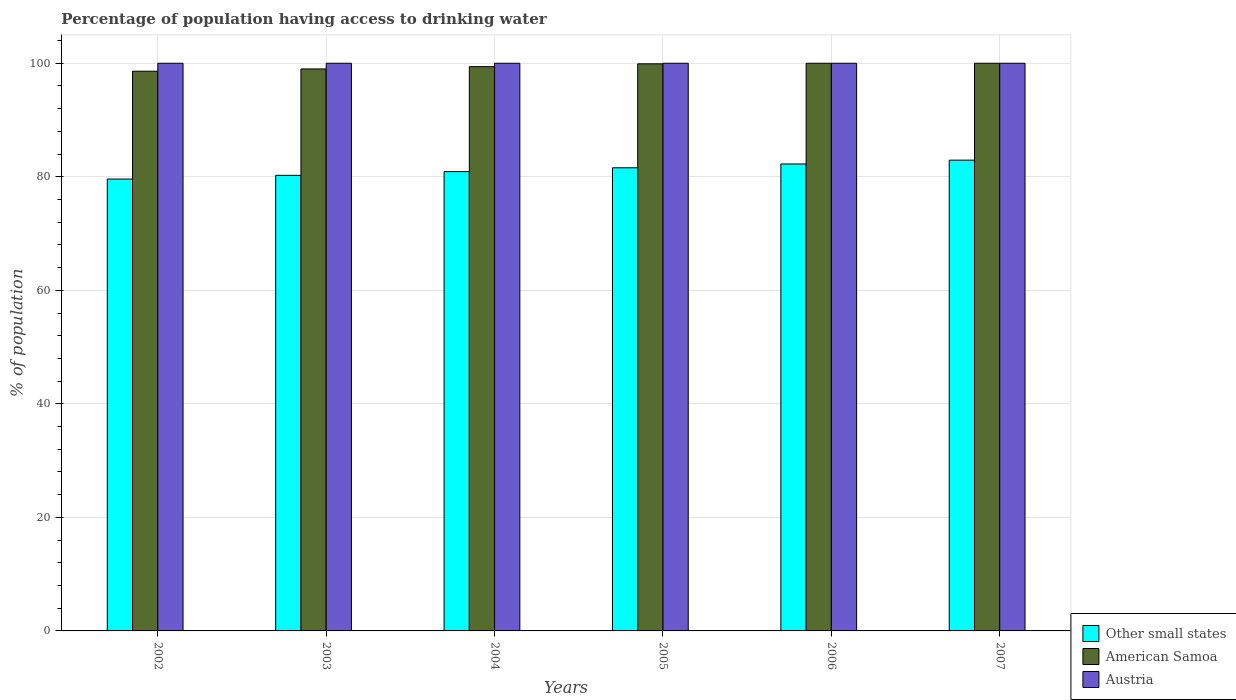How many different coloured bars are there?
Provide a short and direct response. 3. How many groups of bars are there?
Give a very brief answer. 6. Are the number of bars on each tick of the X-axis equal?
Give a very brief answer. Yes. How many bars are there on the 3rd tick from the left?
Offer a very short reply. 3. What is the label of the 2nd group of bars from the left?
Provide a short and direct response. 2003. In how many cases, is the number of bars for a given year not equal to the number of legend labels?
Make the answer very short. 0. What is the percentage of population having access to drinking water in American Samoa in 2005?
Your answer should be compact. 99.9. Across all years, what is the maximum percentage of population having access to drinking water in American Samoa?
Offer a terse response. 100. Across all years, what is the minimum percentage of population having access to drinking water in Austria?
Offer a very short reply. 100. In which year was the percentage of population having access to drinking water in Austria minimum?
Your response must be concise. 2002. What is the total percentage of population having access to drinking water in Austria in the graph?
Your response must be concise. 600. What is the difference between the percentage of population having access to drinking water in Other small states in 2005 and that in 2007?
Your answer should be very brief. -1.35. What is the difference between the percentage of population having access to drinking water in Austria in 2005 and the percentage of population having access to drinking water in Other small states in 2006?
Provide a succinct answer. 17.74. In the year 2005, what is the difference between the percentage of population having access to drinking water in American Samoa and percentage of population having access to drinking water in Other small states?
Make the answer very short. 18.31. What is the ratio of the percentage of population having access to drinking water in Other small states in 2002 to that in 2005?
Offer a very short reply. 0.98. What is the difference between the highest and the second highest percentage of population having access to drinking water in Other small states?
Give a very brief answer. 0.68. What is the difference between the highest and the lowest percentage of population having access to drinking water in Other small states?
Your answer should be very brief. 3.33. In how many years, is the percentage of population having access to drinking water in Other small states greater than the average percentage of population having access to drinking water in Other small states taken over all years?
Your answer should be compact. 3. Is the sum of the percentage of population having access to drinking water in Austria in 2003 and 2006 greater than the maximum percentage of population having access to drinking water in Other small states across all years?
Provide a succinct answer. Yes. What does the 3rd bar from the left in 2005 represents?
Your answer should be very brief. Austria. What does the 3rd bar from the right in 2003 represents?
Offer a very short reply. Other small states. Is it the case that in every year, the sum of the percentage of population having access to drinking water in American Samoa and percentage of population having access to drinking water in Other small states is greater than the percentage of population having access to drinking water in Austria?
Ensure brevity in your answer.  Yes. How many bars are there?
Your answer should be very brief. 18. Are all the bars in the graph horizontal?
Offer a terse response. No. How many years are there in the graph?
Offer a very short reply. 6. What is the difference between two consecutive major ticks on the Y-axis?
Provide a succinct answer. 20. Are the values on the major ticks of Y-axis written in scientific E-notation?
Provide a succinct answer. No. Does the graph contain any zero values?
Make the answer very short. No. Where does the legend appear in the graph?
Your response must be concise. Bottom right. What is the title of the graph?
Offer a very short reply. Percentage of population having access to drinking water. What is the label or title of the X-axis?
Offer a very short reply. Years. What is the label or title of the Y-axis?
Ensure brevity in your answer.  % of population. What is the % of population in Other small states in 2002?
Offer a very short reply. 79.61. What is the % of population of American Samoa in 2002?
Make the answer very short. 98.6. What is the % of population in Other small states in 2003?
Your answer should be compact. 80.26. What is the % of population of American Samoa in 2003?
Your answer should be compact. 99. What is the % of population in Other small states in 2004?
Make the answer very short. 80.91. What is the % of population of American Samoa in 2004?
Ensure brevity in your answer.  99.4. What is the % of population in Other small states in 2005?
Your answer should be very brief. 81.59. What is the % of population in American Samoa in 2005?
Keep it short and to the point. 99.9. What is the % of population of Other small states in 2006?
Offer a very short reply. 82.26. What is the % of population of Austria in 2006?
Ensure brevity in your answer.  100. What is the % of population in Other small states in 2007?
Your answer should be very brief. 82.94. What is the % of population of American Samoa in 2007?
Offer a very short reply. 100. Across all years, what is the maximum % of population in Other small states?
Offer a very short reply. 82.94. Across all years, what is the minimum % of population in Other small states?
Provide a short and direct response. 79.61. Across all years, what is the minimum % of population of American Samoa?
Provide a succinct answer. 98.6. What is the total % of population of Other small states in the graph?
Provide a short and direct response. 487.56. What is the total % of population of American Samoa in the graph?
Give a very brief answer. 596.9. What is the total % of population in Austria in the graph?
Your answer should be very brief. 600. What is the difference between the % of population of Other small states in 2002 and that in 2003?
Your answer should be compact. -0.65. What is the difference between the % of population of American Samoa in 2002 and that in 2003?
Provide a succinct answer. -0.4. What is the difference between the % of population in Austria in 2002 and that in 2003?
Your answer should be compact. 0. What is the difference between the % of population of Other small states in 2002 and that in 2004?
Keep it short and to the point. -1.31. What is the difference between the % of population of American Samoa in 2002 and that in 2004?
Provide a short and direct response. -0.8. What is the difference between the % of population of Austria in 2002 and that in 2004?
Make the answer very short. 0. What is the difference between the % of population in Other small states in 2002 and that in 2005?
Your answer should be compact. -1.98. What is the difference between the % of population of Other small states in 2002 and that in 2006?
Keep it short and to the point. -2.65. What is the difference between the % of population in Austria in 2002 and that in 2006?
Your answer should be compact. 0. What is the difference between the % of population in Other small states in 2002 and that in 2007?
Your response must be concise. -3.33. What is the difference between the % of population of Austria in 2002 and that in 2007?
Your answer should be very brief. 0. What is the difference between the % of population of Other small states in 2003 and that in 2004?
Provide a short and direct response. -0.66. What is the difference between the % of population in Other small states in 2003 and that in 2005?
Ensure brevity in your answer.  -1.33. What is the difference between the % of population of American Samoa in 2003 and that in 2005?
Provide a succinct answer. -0.9. What is the difference between the % of population in Other small states in 2003 and that in 2006?
Ensure brevity in your answer.  -2. What is the difference between the % of population in Other small states in 2003 and that in 2007?
Provide a succinct answer. -2.68. What is the difference between the % of population in American Samoa in 2003 and that in 2007?
Give a very brief answer. -1. What is the difference between the % of population in Austria in 2003 and that in 2007?
Provide a succinct answer. 0. What is the difference between the % of population of Other small states in 2004 and that in 2005?
Make the answer very short. -0.67. What is the difference between the % of population of American Samoa in 2004 and that in 2005?
Make the answer very short. -0.5. What is the difference between the % of population in Other small states in 2004 and that in 2006?
Your answer should be compact. -1.34. What is the difference between the % of population in American Samoa in 2004 and that in 2006?
Keep it short and to the point. -0.6. What is the difference between the % of population of Austria in 2004 and that in 2006?
Provide a short and direct response. 0. What is the difference between the % of population of Other small states in 2004 and that in 2007?
Provide a short and direct response. -2.02. What is the difference between the % of population of Other small states in 2005 and that in 2006?
Your answer should be compact. -0.67. What is the difference between the % of population in Austria in 2005 and that in 2006?
Ensure brevity in your answer.  0. What is the difference between the % of population of Other small states in 2005 and that in 2007?
Your response must be concise. -1.35. What is the difference between the % of population of Other small states in 2006 and that in 2007?
Provide a short and direct response. -0.68. What is the difference between the % of population in American Samoa in 2006 and that in 2007?
Make the answer very short. 0. What is the difference between the % of population in Other small states in 2002 and the % of population in American Samoa in 2003?
Provide a short and direct response. -19.39. What is the difference between the % of population of Other small states in 2002 and the % of population of Austria in 2003?
Your response must be concise. -20.39. What is the difference between the % of population in Other small states in 2002 and the % of population in American Samoa in 2004?
Provide a succinct answer. -19.79. What is the difference between the % of population of Other small states in 2002 and the % of population of Austria in 2004?
Your answer should be very brief. -20.39. What is the difference between the % of population of American Samoa in 2002 and the % of population of Austria in 2004?
Your answer should be compact. -1.4. What is the difference between the % of population of Other small states in 2002 and the % of population of American Samoa in 2005?
Your answer should be compact. -20.29. What is the difference between the % of population of Other small states in 2002 and the % of population of Austria in 2005?
Your response must be concise. -20.39. What is the difference between the % of population of American Samoa in 2002 and the % of population of Austria in 2005?
Ensure brevity in your answer.  -1.4. What is the difference between the % of population of Other small states in 2002 and the % of population of American Samoa in 2006?
Your answer should be compact. -20.39. What is the difference between the % of population in Other small states in 2002 and the % of population in Austria in 2006?
Offer a terse response. -20.39. What is the difference between the % of population of Other small states in 2002 and the % of population of American Samoa in 2007?
Your answer should be compact. -20.39. What is the difference between the % of population in Other small states in 2002 and the % of population in Austria in 2007?
Give a very brief answer. -20.39. What is the difference between the % of population in Other small states in 2003 and the % of population in American Samoa in 2004?
Your answer should be very brief. -19.14. What is the difference between the % of population in Other small states in 2003 and the % of population in Austria in 2004?
Provide a succinct answer. -19.74. What is the difference between the % of population in American Samoa in 2003 and the % of population in Austria in 2004?
Make the answer very short. -1. What is the difference between the % of population in Other small states in 2003 and the % of population in American Samoa in 2005?
Your answer should be very brief. -19.64. What is the difference between the % of population of Other small states in 2003 and the % of population of Austria in 2005?
Offer a terse response. -19.74. What is the difference between the % of population in American Samoa in 2003 and the % of population in Austria in 2005?
Ensure brevity in your answer.  -1. What is the difference between the % of population of Other small states in 2003 and the % of population of American Samoa in 2006?
Offer a terse response. -19.74. What is the difference between the % of population of Other small states in 2003 and the % of population of Austria in 2006?
Provide a succinct answer. -19.74. What is the difference between the % of population in Other small states in 2003 and the % of population in American Samoa in 2007?
Keep it short and to the point. -19.74. What is the difference between the % of population of Other small states in 2003 and the % of population of Austria in 2007?
Give a very brief answer. -19.74. What is the difference between the % of population of Other small states in 2004 and the % of population of American Samoa in 2005?
Keep it short and to the point. -18.99. What is the difference between the % of population of Other small states in 2004 and the % of population of Austria in 2005?
Provide a short and direct response. -19.09. What is the difference between the % of population in American Samoa in 2004 and the % of population in Austria in 2005?
Your response must be concise. -0.6. What is the difference between the % of population in Other small states in 2004 and the % of population in American Samoa in 2006?
Make the answer very short. -19.09. What is the difference between the % of population in Other small states in 2004 and the % of population in Austria in 2006?
Your answer should be compact. -19.09. What is the difference between the % of population of Other small states in 2004 and the % of population of American Samoa in 2007?
Provide a succinct answer. -19.09. What is the difference between the % of population in Other small states in 2004 and the % of population in Austria in 2007?
Provide a short and direct response. -19.09. What is the difference between the % of population of Other small states in 2005 and the % of population of American Samoa in 2006?
Your answer should be very brief. -18.41. What is the difference between the % of population in Other small states in 2005 and the % of population in Austria in 2006?
Your answer should be compact. -18.41. What is the difference between the % of population in Other small states in 2005 and the % of population in American Samoa in 2007?
Your response must be concise. -18.41. What is the difference between the % of population in Other small states in 2005 and the % of population in Austria in 2007?
Ensure brevity in your answer.  -18.41. What is the difference between the % of population of American Samoa in 2005 and the % of population of Austria in 2007?
Offer a terse response. -0.1. What is the difference between the % of population in Other small states in 2006 and the % of population in American Samoa in 2007?
Give a very brief answer. -17.74. What is the difference between the % of population of Other small states in 2006 and the % of population of Austria in 2007?
Keep it short and to the point. -17.74. What is the difference between the % of population of American Samoa in 2006 and the % of population of Austria in 2007?
Keep it short and to the point. 0. What is the average % of population in Other small states per year?
Your response must be concise. 81.26. What is the average % of population of American Samoa per year?
Your answer should be compact. 99.48. What is the average % of population in Austria per year?
Make the answer very short. 100. In the year 2002, what is the difference between the % of population of Other small states and % of population of American Samoa?
Provide a succinct answer. -18.99. In the year 2002, what is the difference between the % of population of Other small states and % of population of Austria?
Your answer should be very brief. -20.39. In the year 2003, what is the difference between the % of population of Other small states and % of population of American Samoa?
Provide a succinct answer. -18.74. In the year 2003, what is the difference between the % of population in Other small states and % of population in Austria?
Offer a terse response. -19.74. In the year 2004, what is the difference between the % of population in Other small states and % of population in American Samoa?
Your answer should be compact. -18.49. In the year 2004, what is the difference between the % of population of Other small states and % of population of Austria?
Your answer should be very brief. -19.09. In the year 2005, what is the difference between the % of population of Other small states and % of population of American Samoa?
Provide a short and direct response. -18.31. In the year 2005, what is the difference between the % of population of Other small states and % of population of Austria?
Provide a short and direct response. -18.41. In the year 2005, what is the difference between the % of population of American Samoa and % of population of Austria?
Offer a very short reply. -0.1. In the year 2006, what is the difference between the % of population in Other small states and % of population in American Samoa?
Your response must be concise. -17.74. In the year 2006, what is the difference between the % of population of Other small states and % of population of Austria?
Provide a short and direct response. -17.74. In the year 2006, what is the difference between the % of population in American Samoa and % of population in Austria?
Your answer should be very brief. 0. In the year 2007, what is the difference between the % of population of Other small states and % of population of American Samoa?
Offer a terse response. -17.06. In the year 2007, what is the difference between the % of population in Other small states and % of population in Austria?
Provide a short and direct response. -17.06. In the year 2007, what is the difference between the % of population in American Samoa and % of population in Austria?
Provide a succinct answer. 0. What is the ratio of the % of population of Other small states in 2002 to that in 2003?
Your answer should be compact. 0.99. What is the ratio of the % of population of American Samoa in 2002 to that in 2003?
Offer a very short reply. 1. What is the ratio of the % of population in Austria in 2002 to that in 2003?
Ensure brevity in your answer.  1. What is the ratio of the % of population of Other small states in 2002 to that in 2004?
Provide a short and direct response. 0.98. What is the ratio of the % of population of Austria in 2002 to that in 2004?
Your answer should be compact. 1. What is the ratio of the % of population in Other small states in 2002 to that in 2005?
Provide a short and direct response. 0.98. What is the ratio of the % of population of American Samoa in 2002 to that in 2005?
Offer a terse response. 0.99. What is the ratio of the % of population of Other small states in 2002 to that in 2006?
Make the answer very short. 0.97. What is the ratio of the % of population of Austria in 2002 to that in 2006?
Your answer should be compact. 1. What is the ratio of the % of population in Other small states in 2002 to that in 2007?
Give a very brief answer. 0.96. What is the ratio of the % of population in Austria in 2002 to that in 2007?
Offer a terse response. 1. What is the ratio of the % of population in American Samoa in 2003 to that in 2004?
Offer a terse response. 1. What is the ratio of the % of population in Austria in 2003 to that in 2004?
Offer a terse response. 1. What is the ratio of the % of population of Other small states in 2003 to that in 2005?
Provide a succinct answer. 0.98. What is the ratio of the % of population in Other small states in 2003 to that in 2006?
Your answer should be compact. 0.98. What is the ratio of the % of population of American Samoa in 2003 to that in 2006?
Make the answer very short. 0.99. What is the ratio of the % of population of Austria in 2003 to that in 2006?
Your answer should be compact. 1. What is the ratio of the % of population in American Samoa in 2003 to that in 2007?
Make the answer very short. 0.99. What is the ratio of the % of population of Austria in 2003 to that in 2007?
Your response must be concise. 1. What is the ratio of the % of population in Other small states in 2004 to that in 2005?
Provide a short and direct response. 0.99. What is the ratio of the % of population of Other small states in 2004 to that in 2006?
Offer a very short reply. 0.98. What is the ratio of the % of population of American Samoa in 2004 to that in 2006?
Ensure brevity in your answer.  0.99. What is the ratio of the % of population in Austria in 2004 to that in 2006?
Keep it short and to the point. 1. What is the ratio of the % of population of Other small states in 2004 to that in 2007?
Ensure brevity in your answer.  0.98. What is the ratio of the % of population of American Samoa in 2004 to that in 2007?
Make the answer very short. 0.99. What is the ratio of the % of population in Austria in 2004 to that in 2007?
Your answer should be very brief. 1. What is the ratio of the % of population in American Samoa in 2005 to that in 2006?
Your answer should be compact. 1. What is the ratio of the % of population of Austria in 2005 to that in 2006?
Ensure brevity in your answer.  1. What is the ratio of the % of population in Other small states in 2005 to that in 2007?
Offer a very short reply. 0.98. What is the ratio of the % of population in American Samoa in 2005 to that in 2007?
Make the answer very short. 1. What is the ratio of the % of population of Other small states in 2006 to that in 2007?
Provide a short and direct response. 0.99. What is the ratio of the % of population of American Samoa in 2006 to that in 2007?
Give a very brief answer. 1. What is the difference between the highest and the second highest % of population of Other small states?
Your answer should be very brief. 0.68. What is the difference between the highest and the second highest % of population of American Samoa?
Give a very brief answer. 0. What is the difference between the highest and the lowest % of population of Other small states?
Ensure brevity in your answer.  3.33. What is the difference between the highest and the lowest % of population in Austria?
Ensure brevity in your answer.  0. 